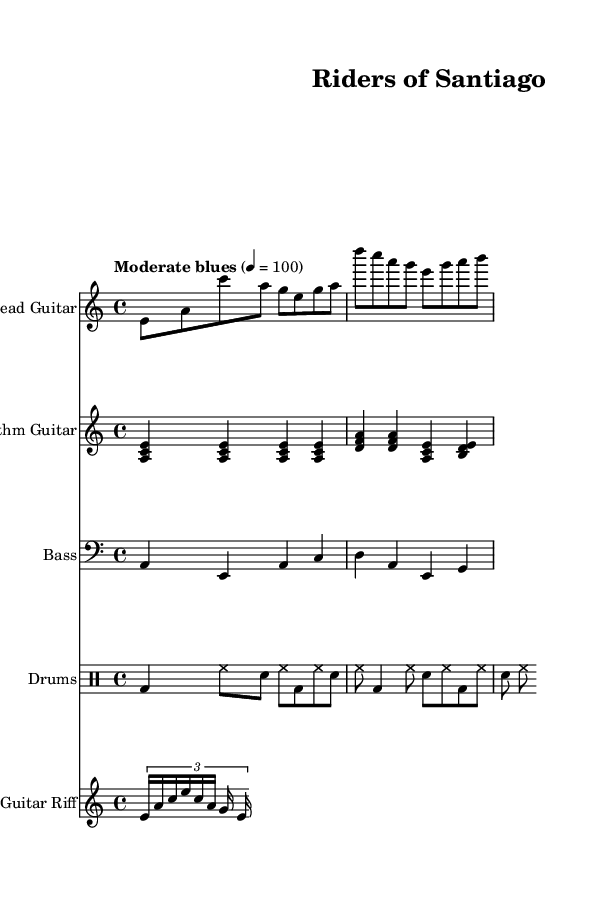What is the key signature of this music? The key signature is A minor. This can be identified by looking at the key signature indicated at the beginning of the music, which shows no sharps or flats and specifically dictates reverence to the A note in a minor framework.
Answer: A minor What is the time signature of the piece? The time signature is 4/4. This is indicated at the beginning of the score and tells us that there are four beats in each measure and a quarter note gets one beat.
Answer: 4/4 What tempo marking is given for the piece? The tempo marking is "Moderate blues," with a metronome marking of 100 beats per minute. This indicates the overall speed of the piece and sets the mood for a blues style.
Answer: Moderate blues How many instruments are featured in this score? There are four instruments featured in this score, which include Lead Guitar, Rhythm Guitar, Bass, and Drums. Each instrument is displayed on separate staves in the score.
Answer: Four What chord is played in the rhythm guitar for the first measure? The chord in the rhythm guitar for the first measure is A minor. This is determined by observing the notes that are played simultaneously on the staff, which correspond to the notes A, C, and E forming the A minor chord.
Answer: A minor Which section introduces a guitar riff? The section that introduces a guitar riff is located after the rhythm guitar part, marked as "Guitar Riff." It has distinct notes that provide a melodic interlude separate from the main guitar parts.
Answer: Guitar Riff What is the primary genre represented in this composition? The primary genre represented in this composition is Electric Blues. This can be inferred from the musical style, structure, and instrumentation that are characteristic of the electric blues genre in contemporary interpretations.
Answer: Electric Blues 